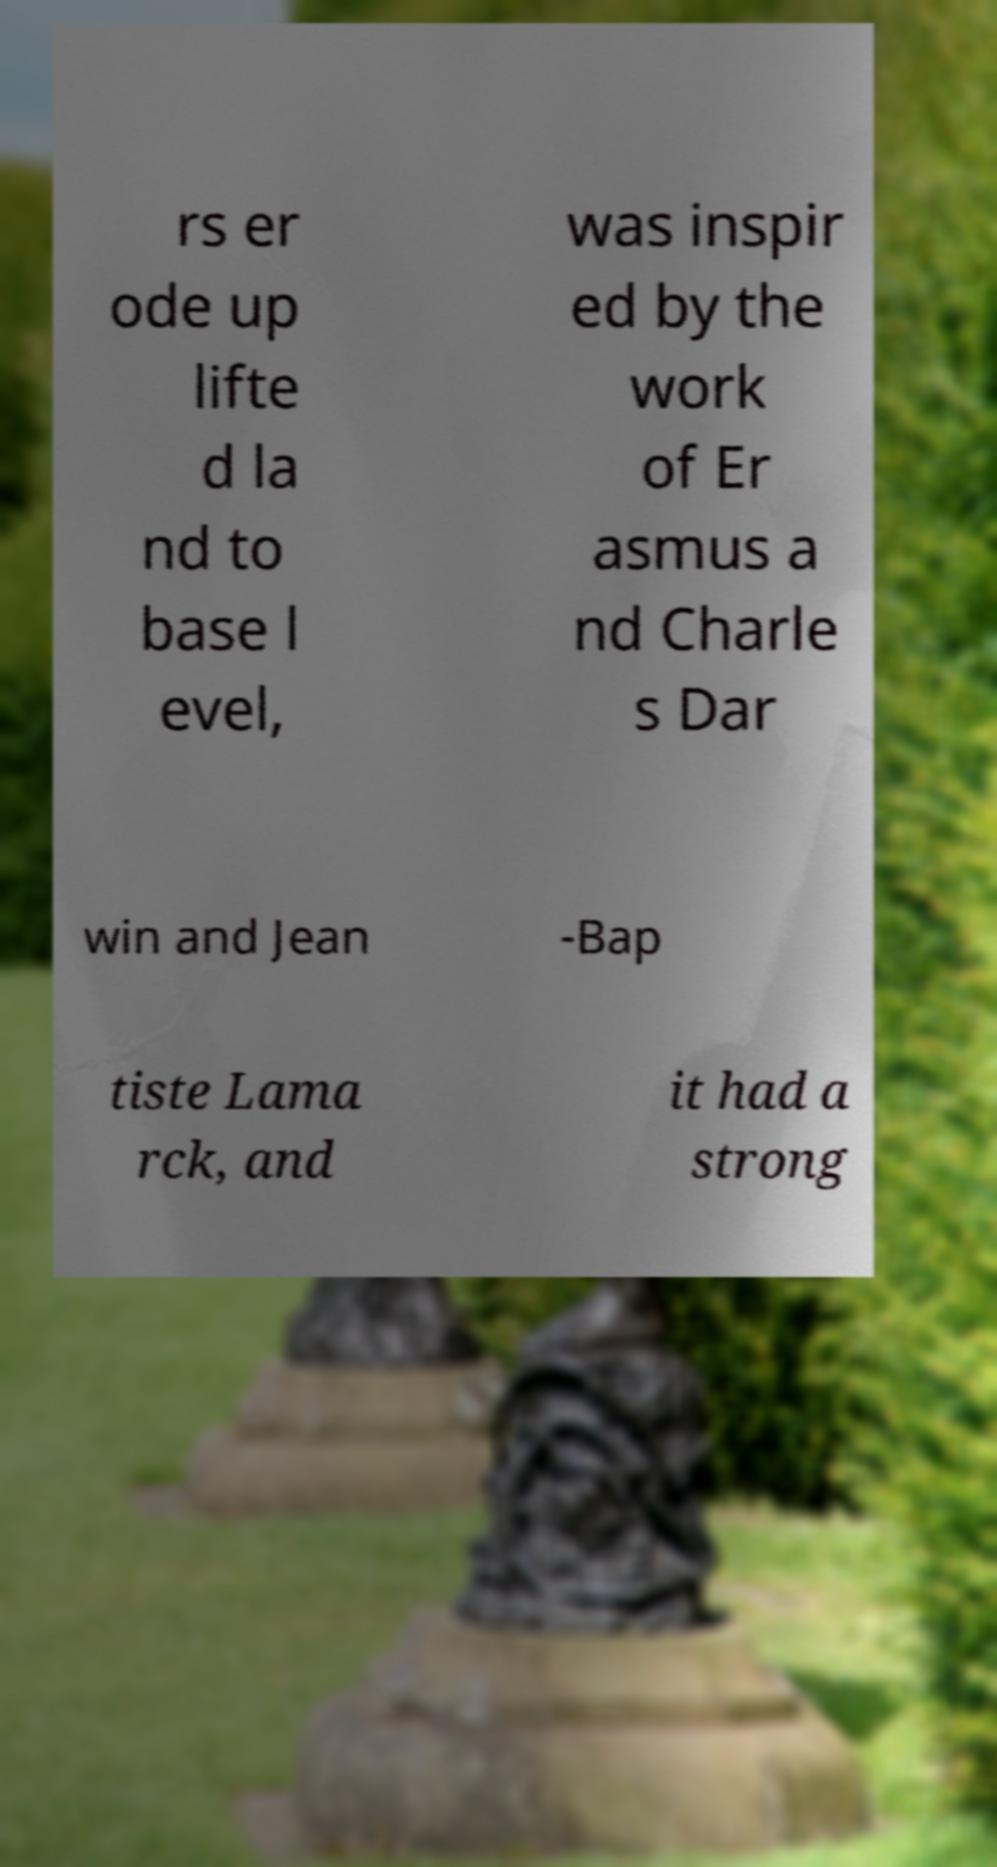Can you read and provide the text displayed in the image?This photo seems to have some interesting text. Can you extract and type it out for me? rs er ode up lifte d la nd to base l evel, was inspir ed by the work of Er asmus a nd Charle s Dar win and Jean -Bap tiste Lama rck, and it had a strong 